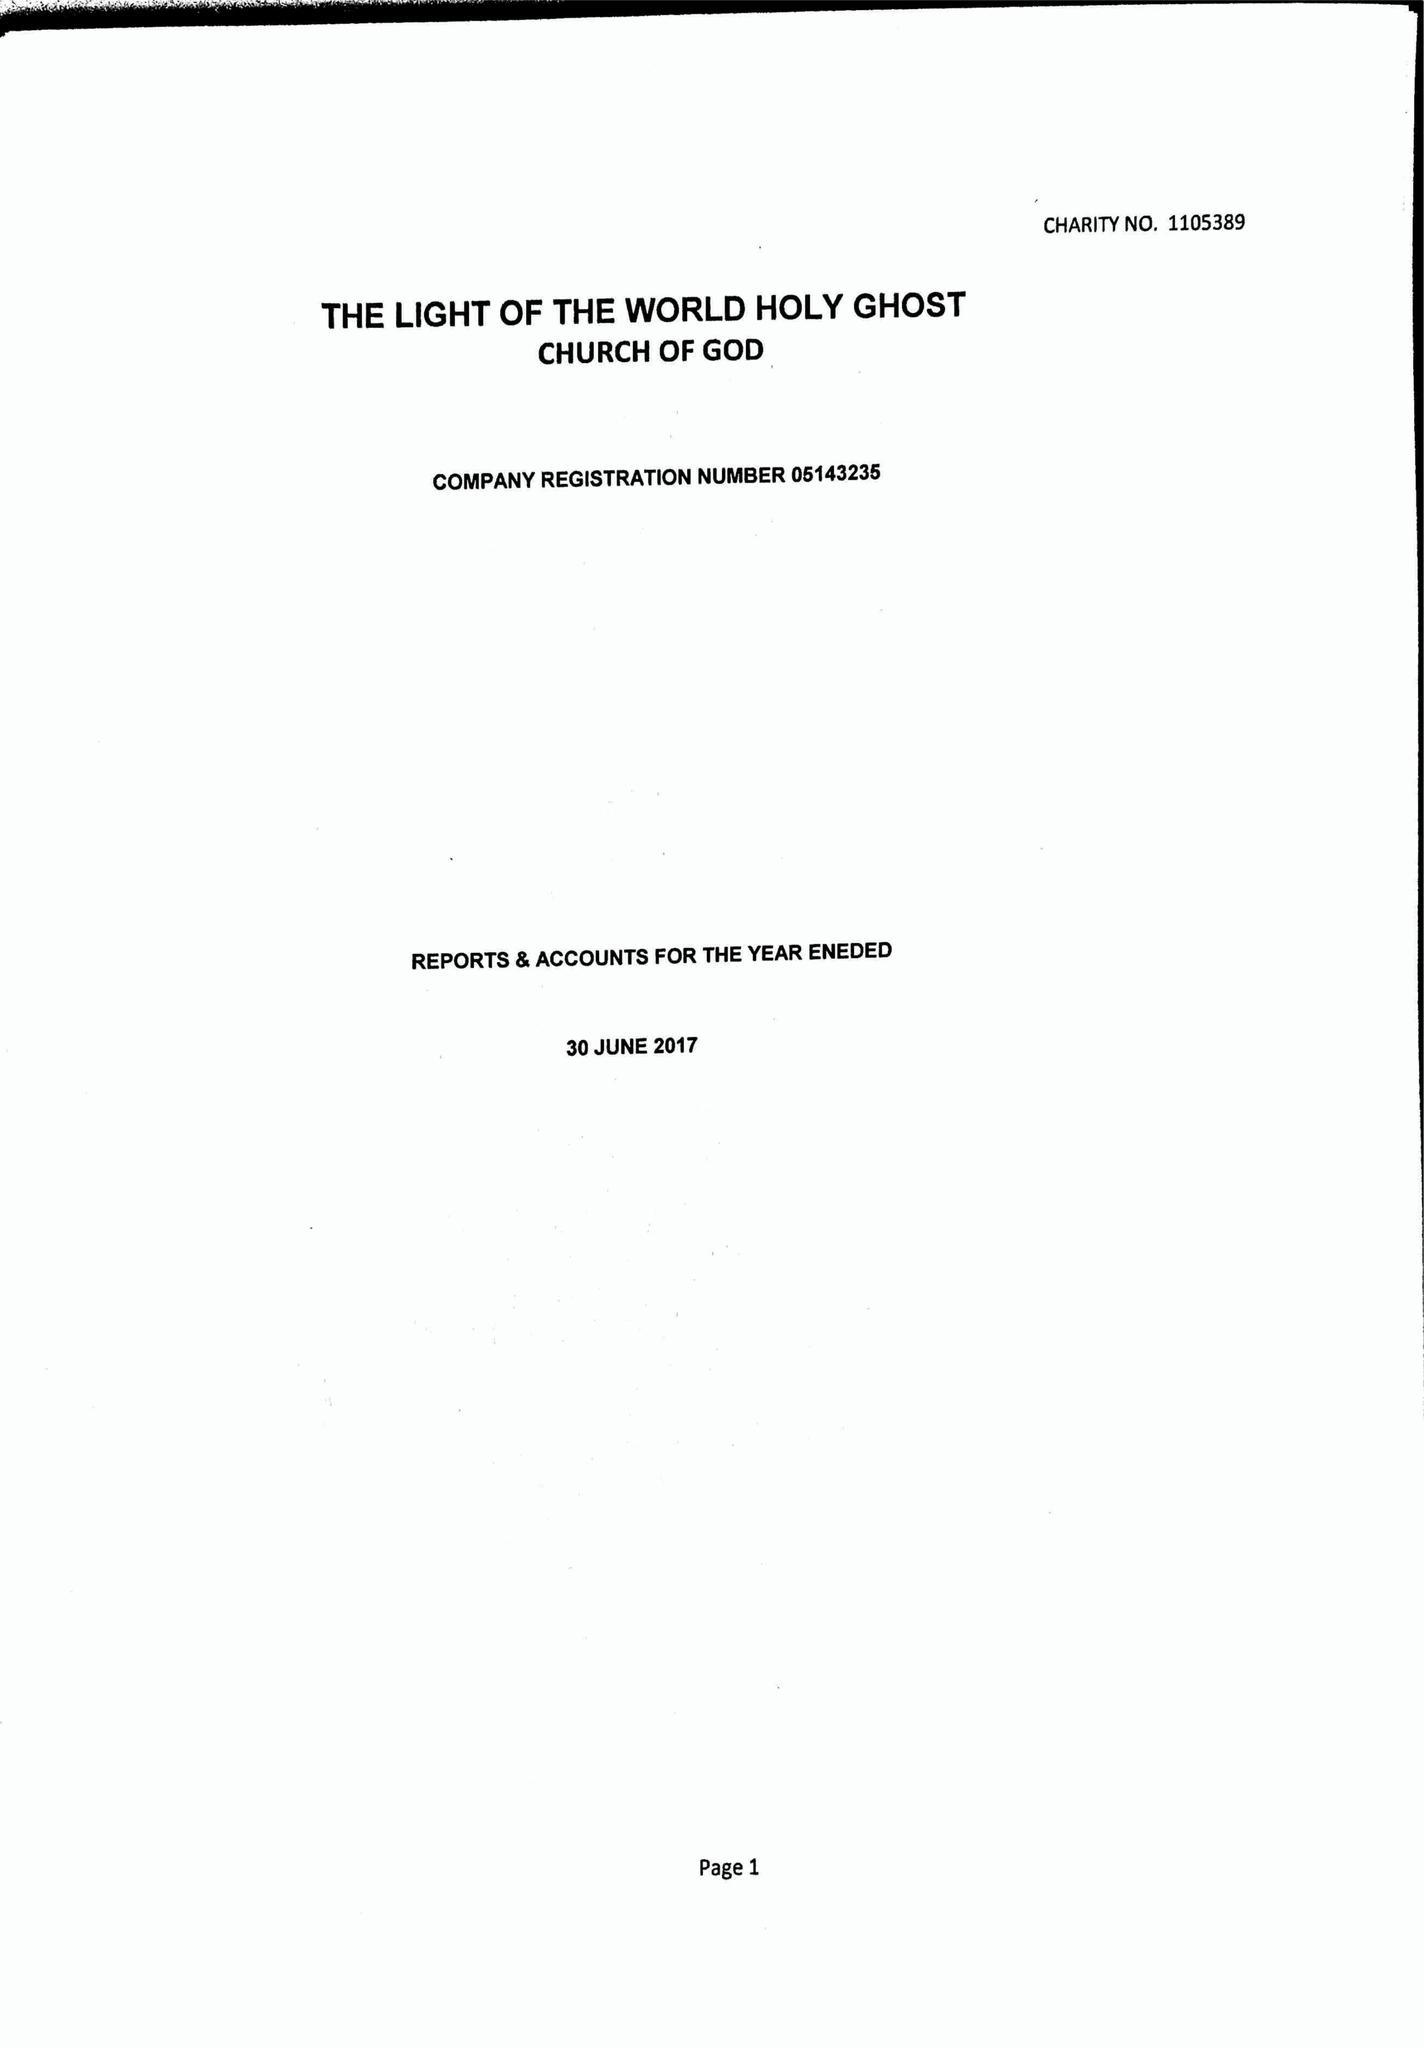What is the value for the address__street_line?
Answer the question using a single word or phrase. 41 DOVER ROAD 